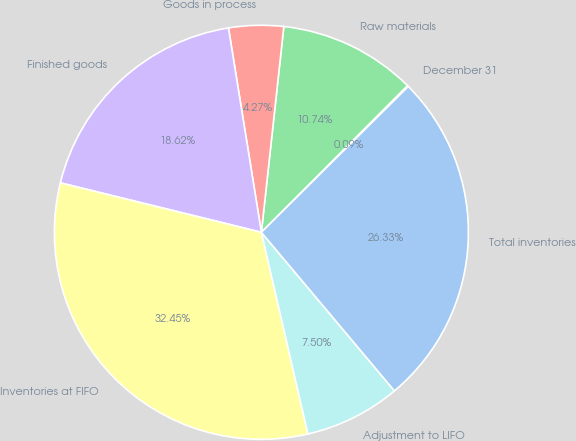Convert chart to OTSL. <chart><loc_0><loc_0><loc_500><loc_500><pie_chart><fcel>December 31<fcel>Raw materials<fcel>Goods in process<fcel>Finished goods<fcel>Inventories at FIFO<fcel>Adjustment to LIFO<fcel>Total inventories<nl><fcel>0.09%<fcel>10.74%<fcel>4.27%<fcel>18.62%<fcel>32.45%<fcel>7.5%<fcel>26.33%<nl></chart> 